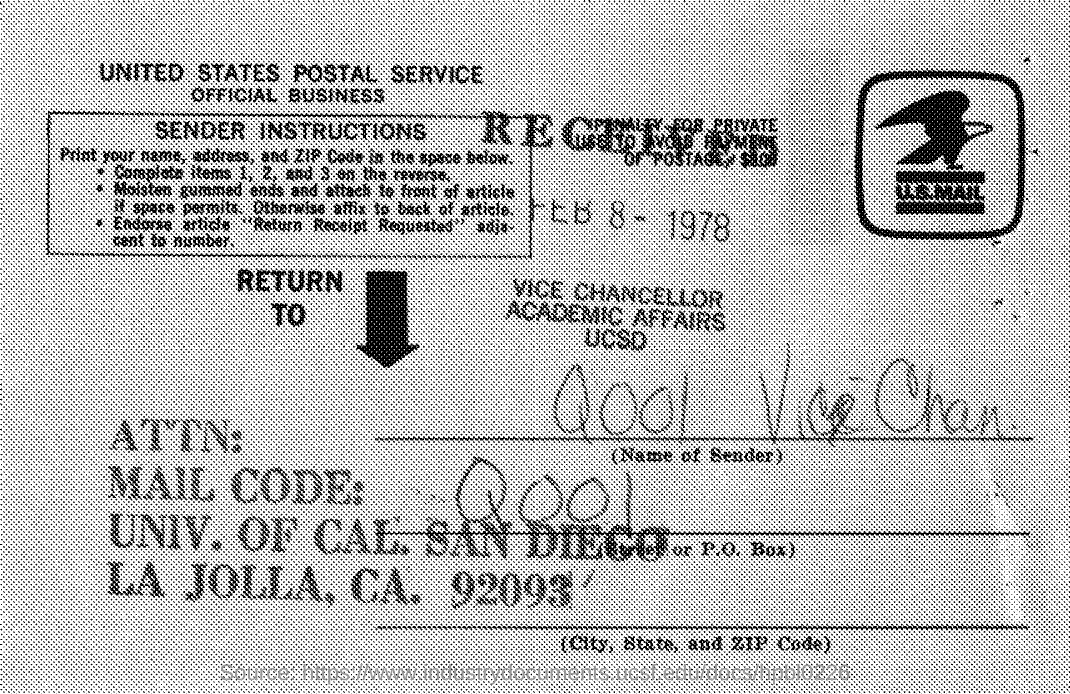Draw attention to some important aspects in this diagram. What is the mail code mentioned in the given post? The service mentioned in the post is the United States Postal Service. 